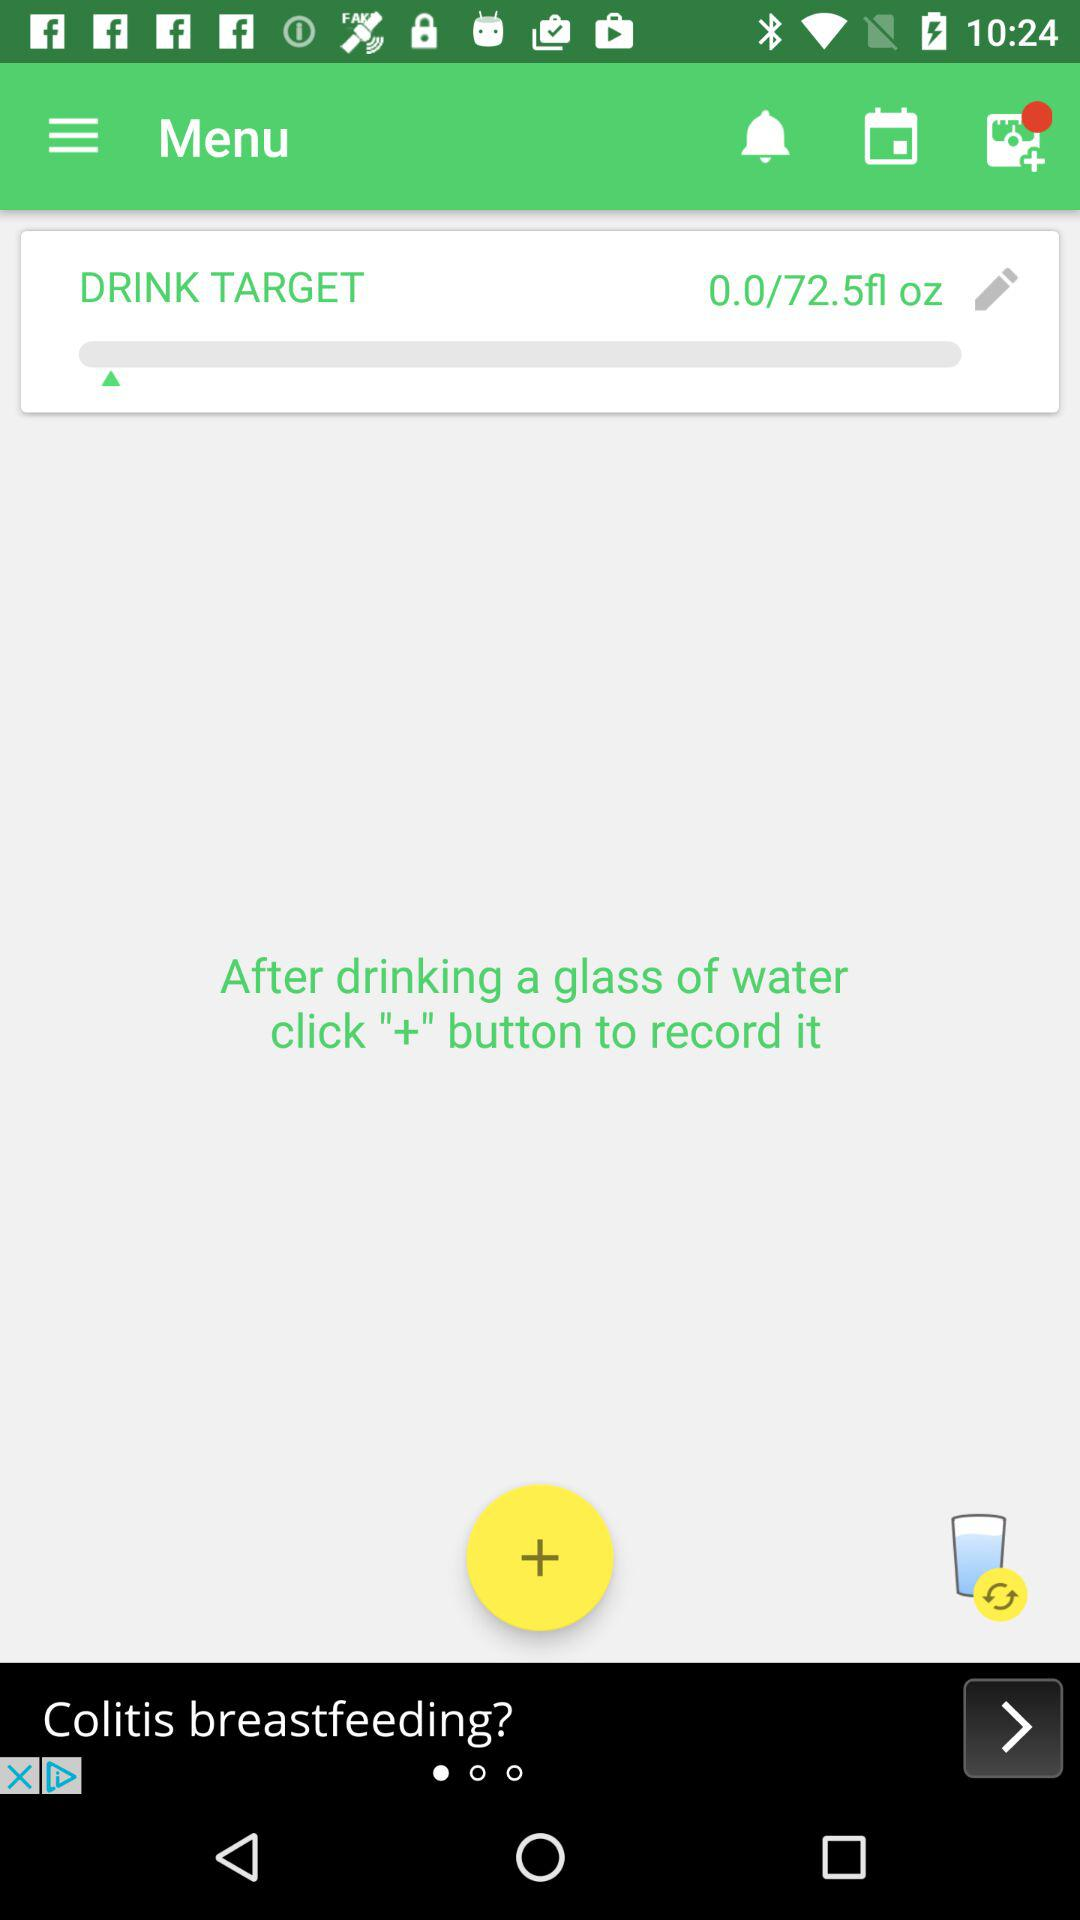What's the total drink target? The total drink target is 72.5 fluid ounces. 